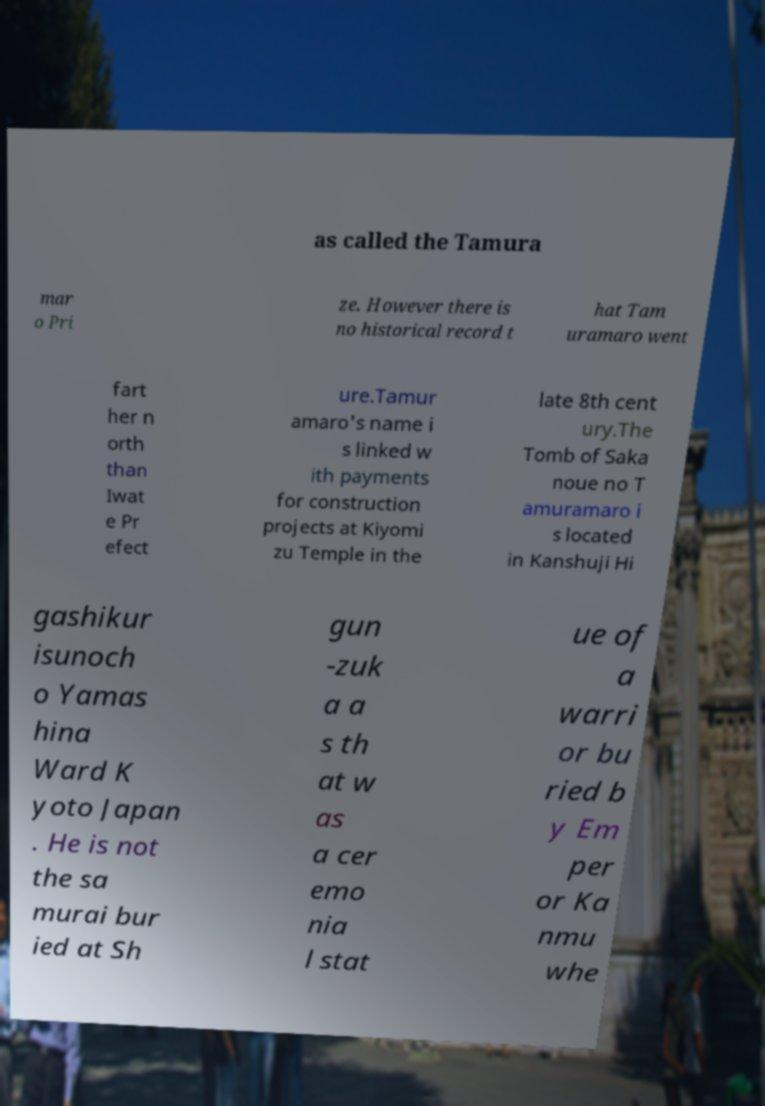There's text embedded in this image that I need extracted. Can you transcribe it verbatim? as called the Tamura mar o Pri ze. However there is no historical record t hat Tam uramaro went fart her n orth than Iwat e Pr efect ure.Tamur amaro's name i s linked w ith payments for construction projects at Kiyomi zu Temple in the late 8th cent ury.The Tomb of Saka noue no T amuramaro i s located in Kanshuji Hi gashikur isunoch o Yamas hina Ward K yoto Japan . He is not the sa murai bur ied at Sh gun -zuk a a s th at w as a cer emo nia l stat ue of a warri or bu ried b y Em per or Ka nmu whe 